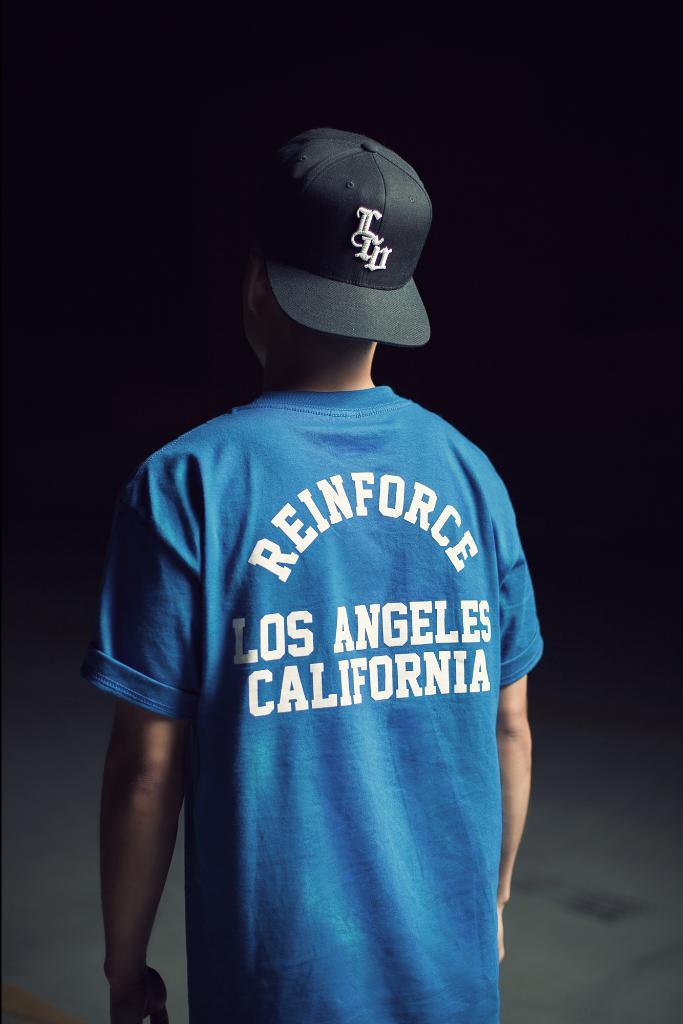Where is los angeles?
Your response must be concise. California. What is the first name on the shirt?
Your response must be concise. Reinforce. 